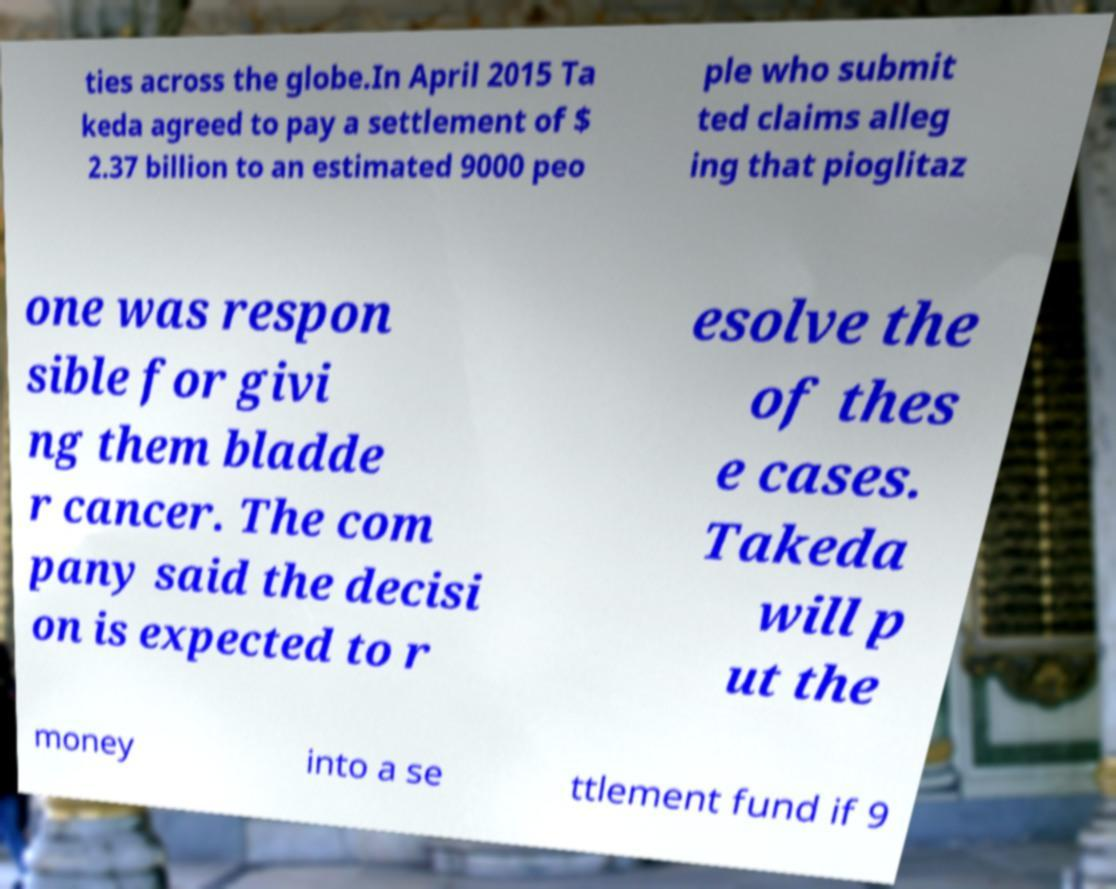Could you extract and type out the text from this image? ties across the globe.In April 2015 Ta keda agreed to pay a settlement of $ 2.37 billion to an estimated 9000 peo ple who submit ted claims alleg ing that pioglitaz one was respon sible for givi ng them bladde r cancer. The com pany said the decisi on is expected to r esolve the of thes e cases. Takeda will p ut the money into a se ttlement fund if 9 